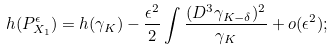Convert formula to latex. <formula><loc_0><loc_0><loc_500><loc_500>h ( P _ { X _ { 1 } } ^ { \epsilon } ) = h ( \gamma _ { K } ) - \frac { \epsilon ^ { 2 } } { 2 } \int \frac { ( D ^ { 3 } \gamma _ { K - \delta } ) ^ { 2 } } { \gamma _ { K } } + o ( \epsilon ^ { 2 } ) ;</formula> 